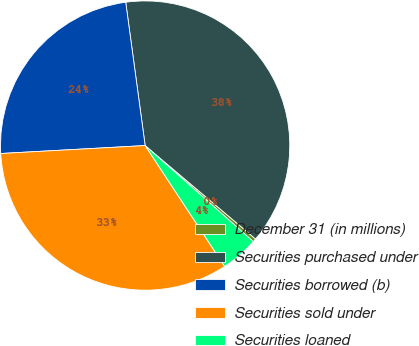Convert chart to OTSL. <chart><loc_0><loc_0><loc_500><loc_500><pie_chart><fcel>December 31 (in millions)<fcel>Securities purchased under<fcel>Securities borrowed (b)<fcel>Securities sold under<fcel>Securities loaned<nl><fcel>0.38%<fcel>38.32%<fcel>23.73%<fcel>33.38%<fcel>4.18%<nl></chart> 